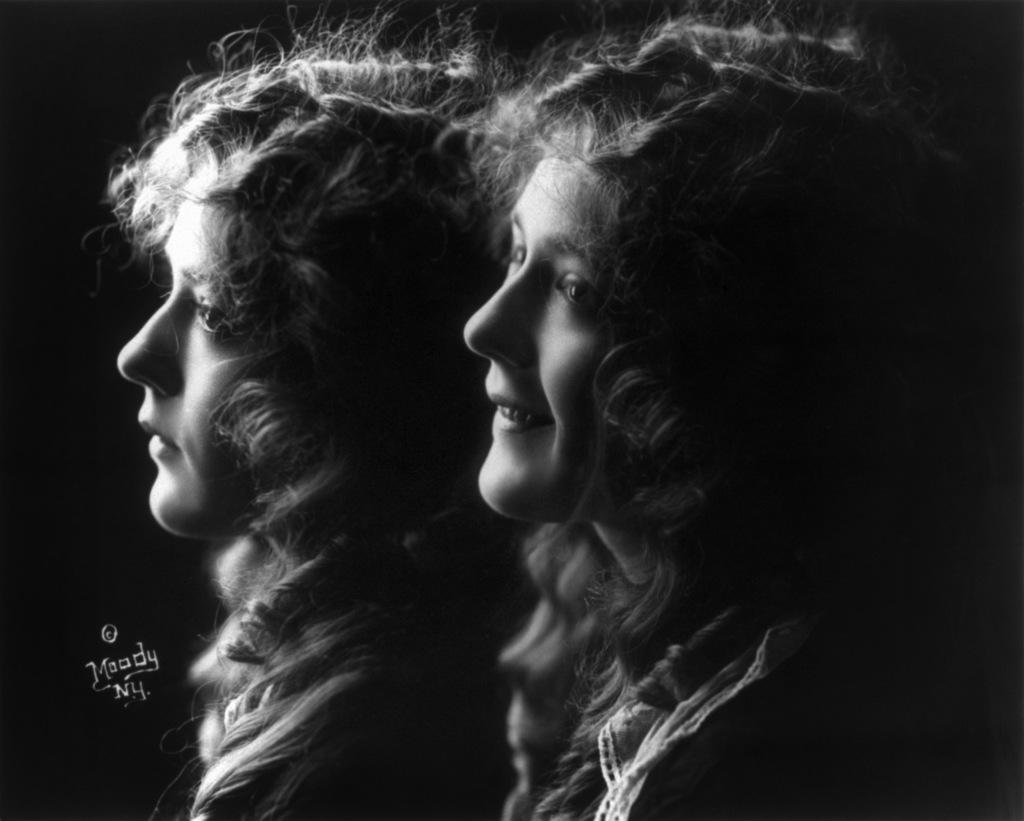Describe this image in one or two sentences. In this image, we can see two girls, there is a dark background. 